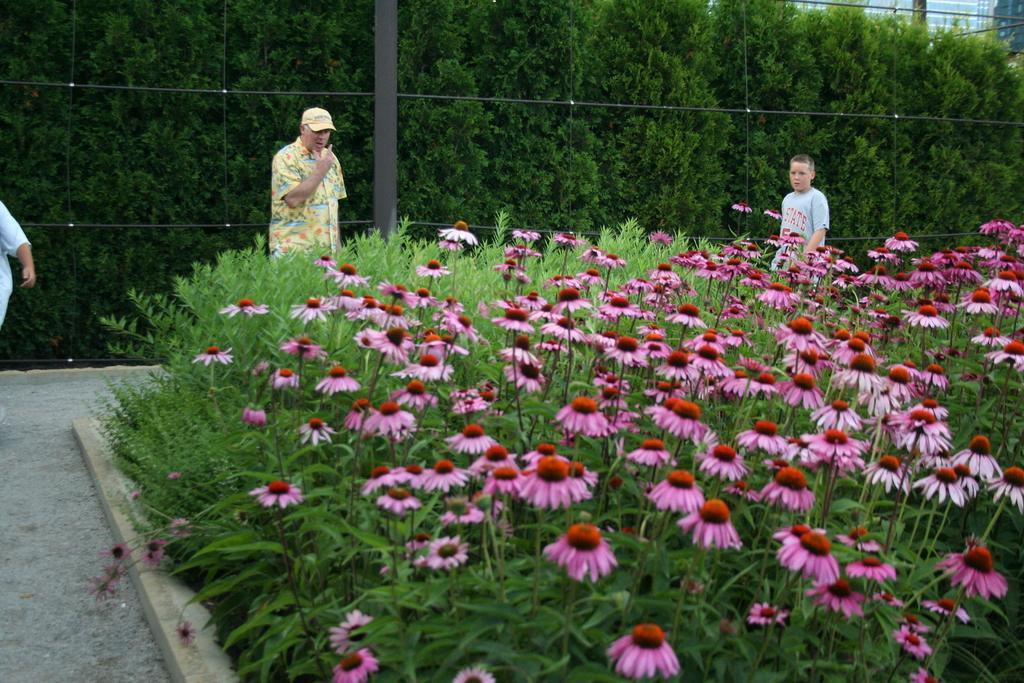Can you describe this image briefly? In the foreground of the picture there are plants, flowers and payment. In the center of the picture there are people standing. In the background there are trees and fencing. At the top right there are buildings. 